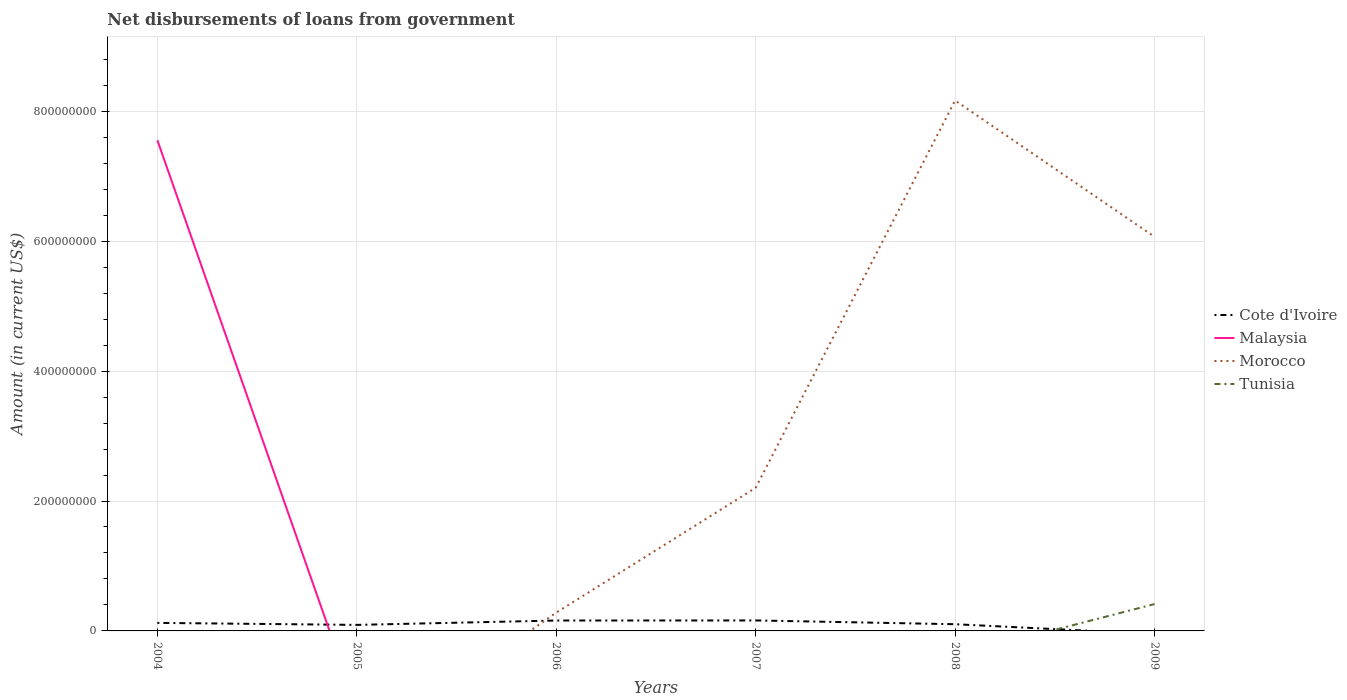How many different coloured lines are there?
Your answer should be very brief. 4. Across all years, what is the maximum amount of loan disbursed from government in Cote d'Ivoire?
Offer a very short reply. 0. What is the total amount of loan disbursed from government in Cote d'Ivoire in the graph?
Your response must be concise. -6.84e+06. What is the difference between the highest and the second highest amount of loan disbursed from government in Morocco?
Provide a succinct answer. 8.17e+08. What is the difference between the highest and the lowest amount of loan disbursed from government in Tunisia?
Keep it short and to the point. 1. How many years are there in the graph?
Offer a terse response. 6. What is the difference between two consecutive major ticks on the Y-axis?
Provide a succinct answer. 2.00e+08. Are the values on the major ticks of Y-axis written in scientific E-notation?
Your response must be concise. No. How many legend labels are there?
Make the answer very short. 4. What is the title of the graph?
Provide a short and direct response. Net disbursements of loans from government. What is the label or title of the X-axis?
Keep it short and to the point. Years. What is the Amount (in current US$) in Cote d'Ivoire in 2004?
Provide a succinct answer. 1.24e+07. What is the Amount (in current US$) in Malaysia in 2004?
Make the answer very short. 7.55e+08. What is the Amount (in current US$) in Morocco in 2004?
Keep it short and to the point. 0. What is the Amount (in current US$) of Cote d'Ivoire in 2005?
Provide a succinct answer. 9.28e+06. What is the Amount (in current US$) of Malaysia in 2005?
Keep it short and to the point. 0. What is the Amount (in current US$) in Morocco in 2005?
Make the answer very short. 0. What is the Amount (in current US$) in Tunisia in 2005?
Your response must be concise. 0. What is the Amount (in current US$) of Cote d'Ivoire in 2006?
Offer a terse response. 1.60e+07. What is the Amount (in current US$) in Morocco in 2006?
Your answer should be compact. 2.82e+07. What is the Amount (in current US$) of Cote d'Ivoire in 2007?
Provide a succinct answer. 1.61e+07. What is the Amount (in current US$) in Malaysia in 2007?
Give a very brief answer. 0. What is the Amount (in current US$) in Morocco in 2007?
Your answer should be compact. 2.20e+08. What is the Amount (in current US$) in Cote d'Ivoire in 2008?
Offer a very short reply. 1.03e+07. What is the Amount (in current US$) in Malaysia in 2008?
Keep it short and to the point. 0. What is the Amount (in current US$) in Morocco in 2008?
Make the answer very short. 8.17e+08. What is the Amount (in current US$) in Tunisia in 2008?
Your answer should be very brief. 0. What is the Amount (in current US$) of Cote d'Ivoire in 2009?
Ensure brevity in your answer.  0. What is the Amount (in current US$) in Malaysia in 2009?
Give a very brief answer. 0. What is the Amount (in current US$) in Morocco in 2009?
Provide a succinct answer. 6.07e+08. What is the Amount (in current US$) of Tunisia in 2009?
Ensure brevity in your answer.  4.13e+07. Across all years, what is the maximum Amount (in current US$) in Cote d'Ivoire?
Offer a very short reply. 1.61e+07. Across all years, what is the maximum Amount (in current US$) in Malaysia?
Keep it short and to the point. 7.55e+08. Across all years, what is the maximum Amount (in current US$) in Morocco?
Make the answer very short. 8.17e+08. Across all years, what is the maximum Amount (in current US$) in Tunisia?
Provide a succinct answer. 4.13e+07. What is the total Amount (in current US$) in Cote d'Ivoire in the graph?
Your answer should be compact. 6.41e+07. What is the total Amount (in current US$) of Malaysia in the graph?
Keep it short and to the point. 7.55e+08. What is the total Amount (in current US$) of Morocco in the graph?
Give a very brief answer. 1.67e+09. What is the total Amount (in current US$) in Tunisia in the graph?
Give a very brief answer. 4.13e+07. What is the difference between the Amount (in current US$) in Cote d'Ivoire in 2004 and that in 2005?
Give a very brief answer. 3.08e+06. What is the difference between the Amount (in current US$) of Cote d'Ivoire in 2004 and that in 2006?
Your answer should be very brief. -3.64e+06. What is the difference between the Amount (in current US$) in Cote d'Ivoire in 2004 and that in 2007?
Provide a succinct answer. -3.76e+06. What is the difference between the Amount (in current US$) of Cote d'Ivoire in 2004 and that in 2008?
Offer a terse response. 2.04e+06. What is the difference between the Amount (in current US$) in Cote d'Ivoire in 2005 and that in 2006?
Your answer should be compact. -6.72e+06. What is the difference between the Amount (in current US$) in Cote d'Ivoire in 2005 and that in 2007?
Give a very brief answer. -6.84e+06. What is the difference between the Amount (in current US$) of Cote d'Ivoire in 2005 and that in 2008?
Offer a very short reply. -1.04e+06. What is the difference between the Amount (in current US$) of Cote d'Ivoire in 2006 and that in 2007?
Give a very brief answer. -1.18e+05. What is the difference between the Amount (in current US$) in Morocco in 2006 and that in 2007?
Offer a very short reply. -1.92e+08. What is the difference between the Amount (in current US$) in Cote d'Ivoire in 2006 and that in 2008?
Offer a terse response. 5.68e+06. What is the difference between the Amount (in current US$) of Morocco in 2006 and that in 2008?
Offer a terse response. -7.88e+08. What is the difference between the Amount (in current US$) in Morocco in 2006 and that in 2009?
Give a very brief answer. -5.78e+08. What is the difference between the Amount (in current US$) in Cote d'Ivoire in 2007 and that in 2008?
Your answer should be compact. 5.80e+06. What is the difference between the Amount (in current US$) in Morocco in 2007 and that in 2008?
Offer a terse response. -5.96e+08. What is the difference between the Amount (in current US$) of Morocco in 2007 and that in 2009?
Make the answer very short. -3.86e+08. What is the difference between the Amount (in current US$) of Morocco in 2008 and that in 2009?
Provide a succinct answer. 2.10e+08. What is the difference between the Amount (in current US$) in Cote d'Ivoire in 2004 and the Amount (in current US$) in Morocco in 2006?
Your answer should be very brief. -1.58e+07. What is the difference between the Amount (in current US$) of Malaysia in 2004 and the Amount (in current US$) of Morocco in 2006?
Ensure brevity in your answer.  7.27e+08. What is the difference between the Amount (in current US$) of Cote d'Ivoire in 2004 and the Amount (in current US$) of Morocco in 2007?
Your answer should be very brief. -2.08e+08. What is the difference between the Amount (in current US$) of Malaysia in 2004 and the Amount (in current US$) of Morocco in 2007?
Keep it short and to the point. 5.35e+08. What is the difference between the Amount (in current US$) of Cote d'Ivoire in 2004 and the Amount (in current US$) of Morocco in 2008?
Your response must be concise. -8.04e+08. What is the difference between the Amount (in current US$) in Malaysia in 2004 and the Amount (in current US$) in Morocco in 2008?
Offer a very short reply. -6.11e+07. What is the difference between the Amount (in current US$) of Cote d'Ivoire in 2004 and the Amount (in current US$) of Morocco in 2009?
Offer a terse response. -5.94e+08. What is the difference between the Amount (in current US$) of Cote d'Ivoire in 2004 and the Amount (in current US$) of Tunisia in 2009?
Keep it short and to the point. -2.90e+07. What is the difference between the Amount (in current US$) in Malaysia in 2004 and the Amount (in current US$) in Morocco in 2009?
Make the answer very short. 1.49e+08. What is the difference between the Amount (in current US$) in Malaysia in 2004 and the Amount (in current US$) in Tunisia in 2009?
Offer a terse response. 7.14e+08. What is the difference between the Amount (in current US$) of Cote d'Ivoire in 2005 and the Amount (in current US$) of Morocco in 2006?
Provide a succinct answer. -1.89e+07. What is the difference between the Amount (in current US$) in Cote d'Ivoire in 2005 and the Amount (in current US$) in Morocco in 2007?
Give a very brief answer. -2.11e+08. What is the difference between the Amount (in current US$) in Cote d'Ivoire in 2005 and the Amount (in current US$) in Morocco in 2008?
Provide a short and direct response. -8.07e+08. What is the difference between the Amount (in current US$) of Cote d'Ivoire in 2005 and the Amount (in current US$) of Morocco in 2009?
Provide a succinct answer. -5.97e+08. What is the difference between the Amount (in current US$) in Cote d'Ivoire in 2005 and the Amount (in current US$) in Tunisia in 2009?
Offer a terse response. -3.21e+07. What is the difference between the Amount (in current US$) of Cote d'Ivoire in 2006 and the Amount (in current US$) of Morocco in 2007?
Provide a succinct answer. -2.04e+08. What is the difference between the Amount (in current US$) of Cote d'Ivoire in 2006 and the Amount (in current US$) of Morocco in 2008?
Give a very brief answer. -8.01e+08. What is the difference between the Amount (in current US$) of Cote d'Ivoire in 2006 and the Amount (in current US$) of Morocco in 2009?
Give a very brief answer. -5.91e+08. What is the difference between the Amount (in current US$) of Cote d'Ivoire in 2006 and the Amount (in current US$) of Tunisia in 2009?
Make the answer very short. -2.53e+07. What is the difference between the Amount (in current US$) of Morocco in 2006 and the Amount (in current US$) of Tunisia in 2009?
Provide a succinct answer. -1.32e+07. What is the difference between the Amount (in current US$) in Cote d'Ivoire in 2007 and the Amount (in current US$) in Morocco in 2008?
Keep it short and to the point. -8.00e+08. What is the difference between the Amount (in current US$) of Cote d'Ivoire in 2007 and the Amount (in current US$) of Morocco in 2009?
Your answer should be very brief. -5.91e+08. What is the difference between the Amount (in current US$) of Cote d'Ivoire in 2007 and the Amount (in current US$) of Tunisia in 2009?
Your response must be concise. -2.52e+07. What is the difference between the Amount (in current US$) of Morocco in 2007 and the Amount (in current US$) of Tunisia in 2009?
Your response must be concise. 1.79e+08. What is the difference between the Amount (in current US$) of Cote d'Ivoire in 2008 and the Amount (in current US$) of Morocco in 2009?
Offer a terse response. -5.96e+08. What is the difference between the Amount (in current US$) of Cote d'Ivoire in 2008 and the Amount (in current US$) of Tunisia in 2009?
Provide a succinct answer. -3.10e+07. What is the difference between the Amount (in current US$) of Morocco in 2008 and the Amount (in current US$) of Tunisia in 2009?
Your answer should be very brief. 7.75e+08. What is the average Amount (in current US$) of Cote d'Ivoire per year?
Your answer should be very brief. 1.07e+07. What is the average Amount (in current US$) of Malaysia per year?
Provide a short and direct response. 1.26e+08. What is the average Amount (in current US$) of Morocco per year?
Your answer should be very brief. 2.79e+08. What is the average Amount (in current US$) of Tunisia per year?
Ensure brevity in your answer.  6.89e+06. In the year 2004, what is the difference between the Amount (in current US$) of Cote d'Ivoire and Amount (in current US$) of Malaysia?
Offer a very short reply. -7.43e+08. In the year 2006, what is the difference between the Amount (in current US$) in Cote d'Ivoire and Amount (in current US$) in Morocco?
Provide a succinct answer. -1.22e+07. In the year 2007, what is the difference between the Amount (in current US$) in Cote d'Ivoire and Amount (in current US$) in Morocco?
Offer a terse response. -2.04e+08. In the year 2008, what is the difference between the Amount (in current US$) in Cote d'Ivoire and Amount (in current US$) in Morocco?
Keep it short and to the point. -8.06e+08. In the year 2009, what is the difference between the Amount (in current US$) in Morocco and Amount (in current US$) in Tunisia?
Ensure brevity in your answer.  5.65e+08. What is the ratio of the Amount (in current US$) in Cote d'Ivoire in 2004 to that in 2005?
Provide a short and direct response. 1.33. What is the ratio of the Amount (in current US$) of Cote d'Ivoire in 2004 to that in 2006?
Give a very brief answer. 0.77. What is the ratio of the Amount (in current US$) of Cote d'Ivoire in 2004 to that in 2007?
Make the answer very short. 0.77. What is the ratio of the Amount (in current US$) of Cote d'Ivoire in 2004 to that in 2008?
Keep it short and to the point. 1.2. What is the ratio of the Amount (in current US$) in Cote d'Ivoire in 2005 to that in 2006?
Offer a very short reply. 0.58. What is the ratio of the Amount (in current US$) of Cote d'Ivoire in 2005 to that in 2007?
Give a very brief answer. 0.58. What is the ratio of the Amount (in current US$) in Cote d'Ivoire in 2005 to that in 2008?
Make the answer very short. 0.9. What is the ratio of the Amount (in current US$) in Morocco in 2006 to that in 2007?
Your answer should be compact. 0.13. What is the ratio of the Amount (in current US$) in Cote d'Ivoire in 2006 to that in 2008?
Make the answer very short. 1.55. What is the ratio of the Amount (in current US$) in Morocco in 2006 to that in 2008?
Ensure brevity in your answer.  0.03. What is the ratio of the Amount (in current US$) of Morocco in 2006 to that in 2009?
Make the answer very short. 0.05. What is the ratio of the Amount (in current US$) of Cote d'Ivoire in 2007 to that in 2008?
Provide a succinct answer. 1.56. What is the ratio of the Amount (in current US$) of Morocco in 2007 to that in 2008?
Offer a very short reply. 0.27. What is the ratio of the Amount (in current US$) of Morocco in 2007 to that in 2009?
Offer a terse response. 0.36. What is the ratio of the Amount (in current US$) of Morocco in 2008 to that in 2009?
Provide a succinct answer. 1.35. What is the difference between the highest and the second highest Amount (in current US$) in Cote d'Ivoire?
Give a very brief answer. 1.18e+05. What is the difference between the highest and the second highest Amount (in current US$) of Morocco?
Provide a succinct answer. 2.10e+08. What is the difference between the highest and the lowest Amount (in current US$) in Cote d'Ivoire?
Ensure brevity in your answer.  1.61e+07. What is the difference between the highest and the lowest Amount (in current US$) in Malaysia?
Offer a very short reply. 7.55e+08. What is the difference between the highest and the lowest Amount (in current US$) in Morocco?
Your response must be concise. 8.17e+08. What is the difference between the highest and the lowest Amount (in current US$) of Tunisia?
Offer a terse response. 4.13e+07. 